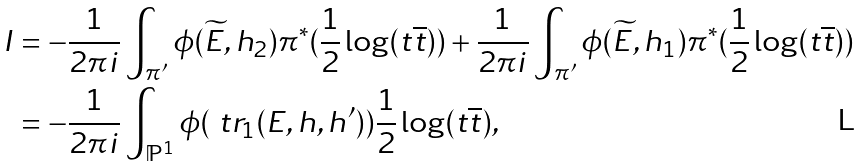Convert formula to latex. <formula><loc_0><loc_0><loc_500><loc_500>I & = - \frac { 1 } { 2 \pi i } \int _ { \pi ^ { \prime } } \phi ( \widetilde { E } , h _ { 2 } ) \pi ^ { \ast } ( \frac { 1 } { 2 } \log ( t \overline { t } ) ) + \frac { 1 } { 2 \pi i } \int _ { \pi ^ { \prime } } \phi ( \widetilde { E } , h _ { 1 } ) \pi ^ { \ast } ( \frac { 1 } { 2 } \log ( t \overline { t } ) ) \\ & = - \frac { 1 } { 2 \pi i } \int _ { \mathbb { P } ^ { 1 } } \phi ( \ t r _ { 1 } ( E , h , h ^ { \prime } ) ) \frac { 1 } { 2 } \log ( t \overline { t } ) ,</formula> 